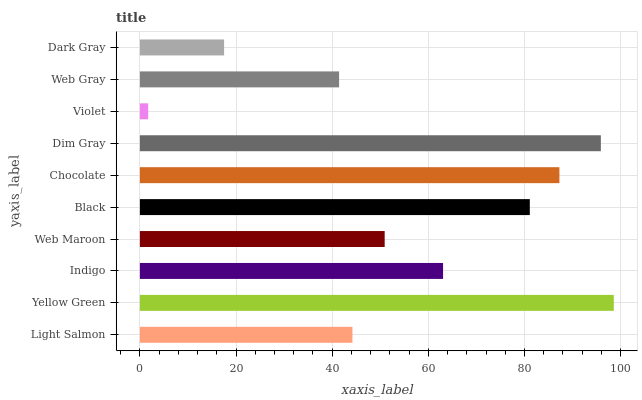Is Violet the minimum?
Answer yes or no. Yes. Is Yellow Green the maximum?
Answer yes or no. Yes. Is Indigo the minimum?
Answer yes or no. No. Is Indigo the maximum?
Answer yes or no. No. Is Yellow Green greater than Indigo?
Answer yes or no. Yes. Is Indigo less than Yellow Green?
Answer yes or no. Yes. Is Indigo greater than Yellow Green?
Answer yes or no. No. Is Yellow Green less than Indigo?
Answer yes or no. No. Is Indigo the high median?
Answer yes or no. Yes. Is Web Maroon the low median?
Answer yes or no. Yes. Is Violet the high median?
Answer yes or no. No. Is Light Salmon the low median?
Answer yes or no. No. 